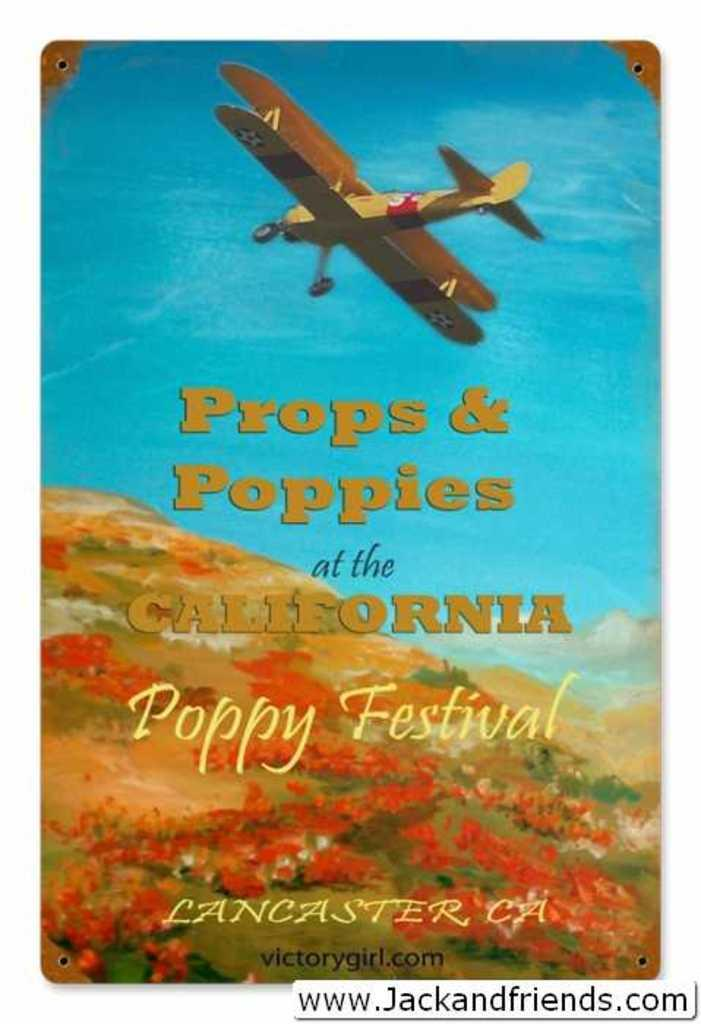What is the main subject of the image? There is an advertisement in the image. How many horses are depicted in the advertisement? There is no information about horses in the image, as it only contains an advertisement. Is there a hydrant visible in the advertisement? There is no information about a hydrant in the image, as it only contains an advertisement. 